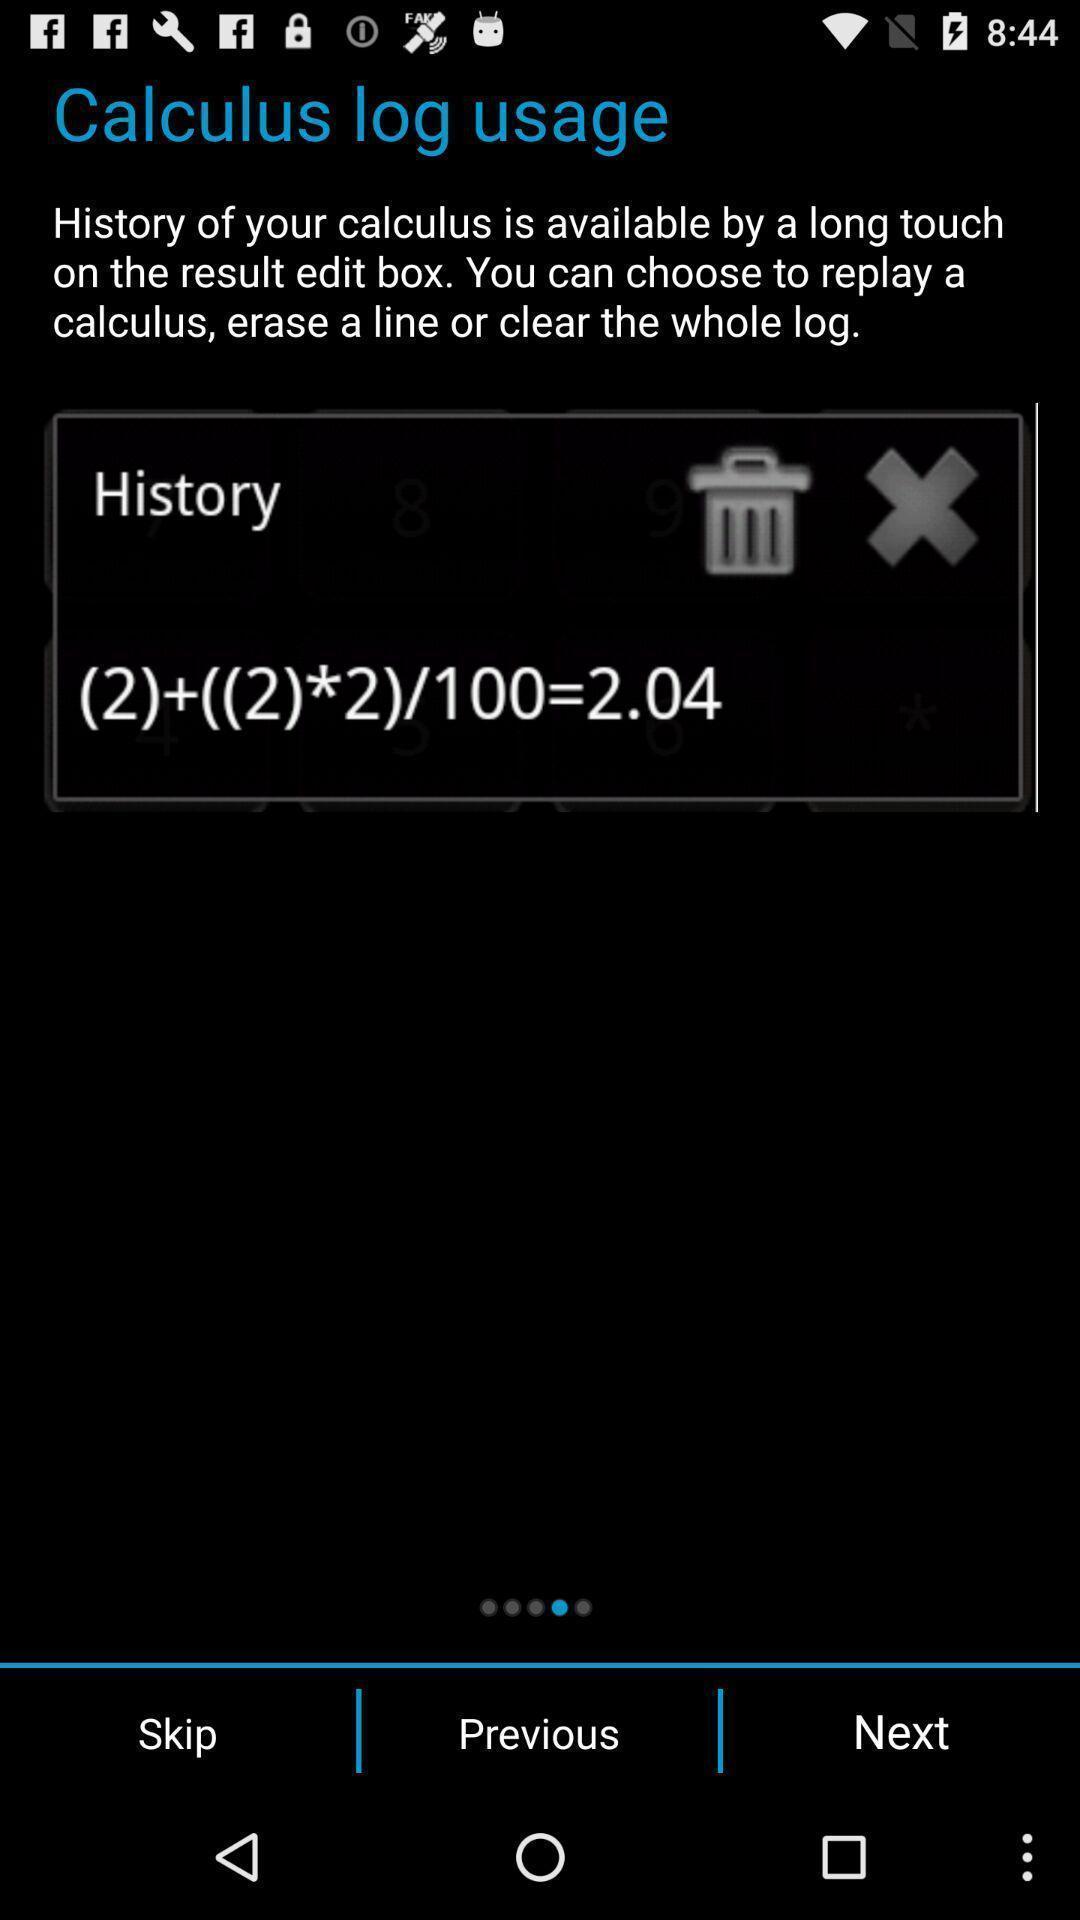What is the overall content of this screenshot? Page showing multiple options with information related to calculus. 